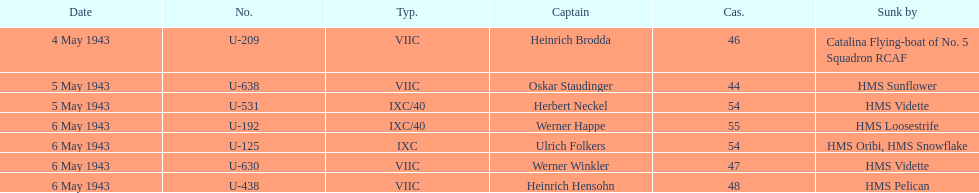Which u-boat was the first to sink U-209. Give me the full table as a dictionary. {'header': ['Date', 'No.', 'Typ.', 'Captain', 'Cas.', 'Sunk by'], 'rows': [['4 May 1943', 'U-209', 'VIIC', 'Heinrich Brodda', '46', 'Catalina Flying-boat of No. 5 Squadron RCAF'], ['5 May 1943', 'U-638', 'VIIC', 'Oskar Staudinger', '44', 'HMS Sunflower'], ['5 May 1943', 'U-531', 'IXC/40', 'Herbert Neckel', '54', 'HMS Vidette'], ['6 May 1943', 'U-192', 'IXC/40', 'Werner Happe', '55', 'HMS Loosestrife'], ['6 May 1943', 'U-125', 'IXC', 'Ulrich Folkers', '54', 'HMS Oribi, HMS Snowflake'], ['6 May 1943', 'U-630', 'VIIC', 'Werner Winkler', '47', 'HMS Vidette'], ['6 May 1943', 'U-438', 'VIIC', 'Heinrich Hensohn', '48', 'HMS Pelican']]} 